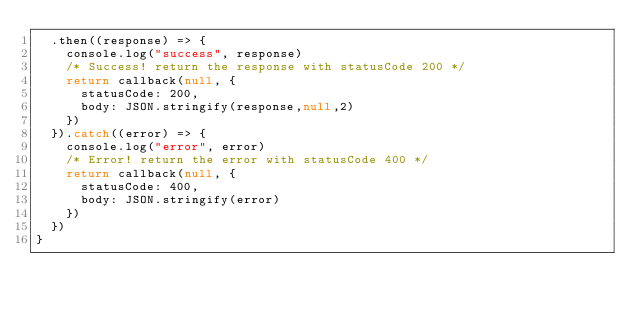Convert code to text. <code><loc_0><loc_0><loc_500><loc_500><_JavaScript_>  .then((response) => {
    console.log("success", response)
    /* Success! return the response with statusCode 200 */
    return callback(null, {
      statusCode: 200,
      body: JSON.stringify(response,null,2)
    })
  }).catch((error) => {
    console.log("error", error)
    /* Error! return the error with statusCode 400 */
    return callback(null, {
      statusCode: 400,
      body: JSON.stringify(error)
    })
  })
}</code> 